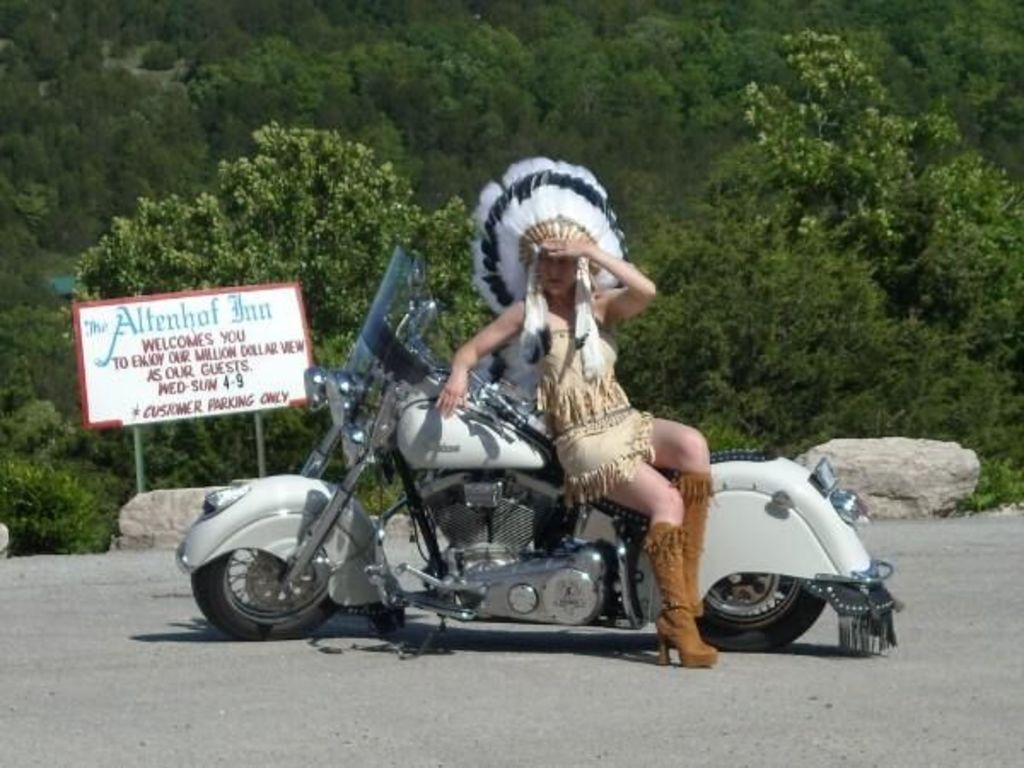How would you summarize this image in a sentence or two? This is a picture taken on a road. In the center of the picture there is a bike and woman sitting on the bike. In the background there is a name board and stones. On the top there are many trees. In the foreground it is road. 